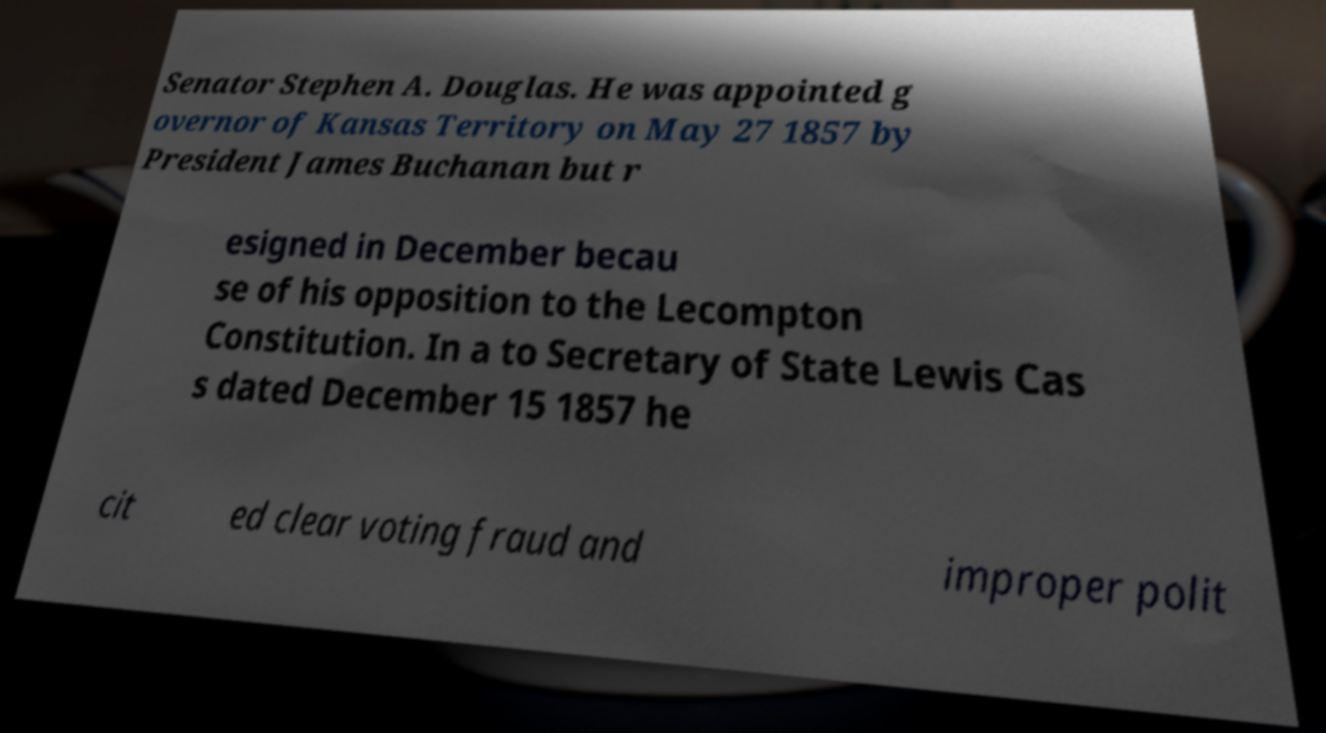Could you assist in decoding the text presented in this image and type it out clearly? Senator Stephen A. Douglas. He was appointed g overnor of Kansas Territory on May 27 1857 by President James Buchanan but r esigned in December becau se of his opposition to the Lecompton Constitution. In a to Secretary of State Lewis Cas s dated December 15 1857 he cit ed clear voting fraud and improper polit 